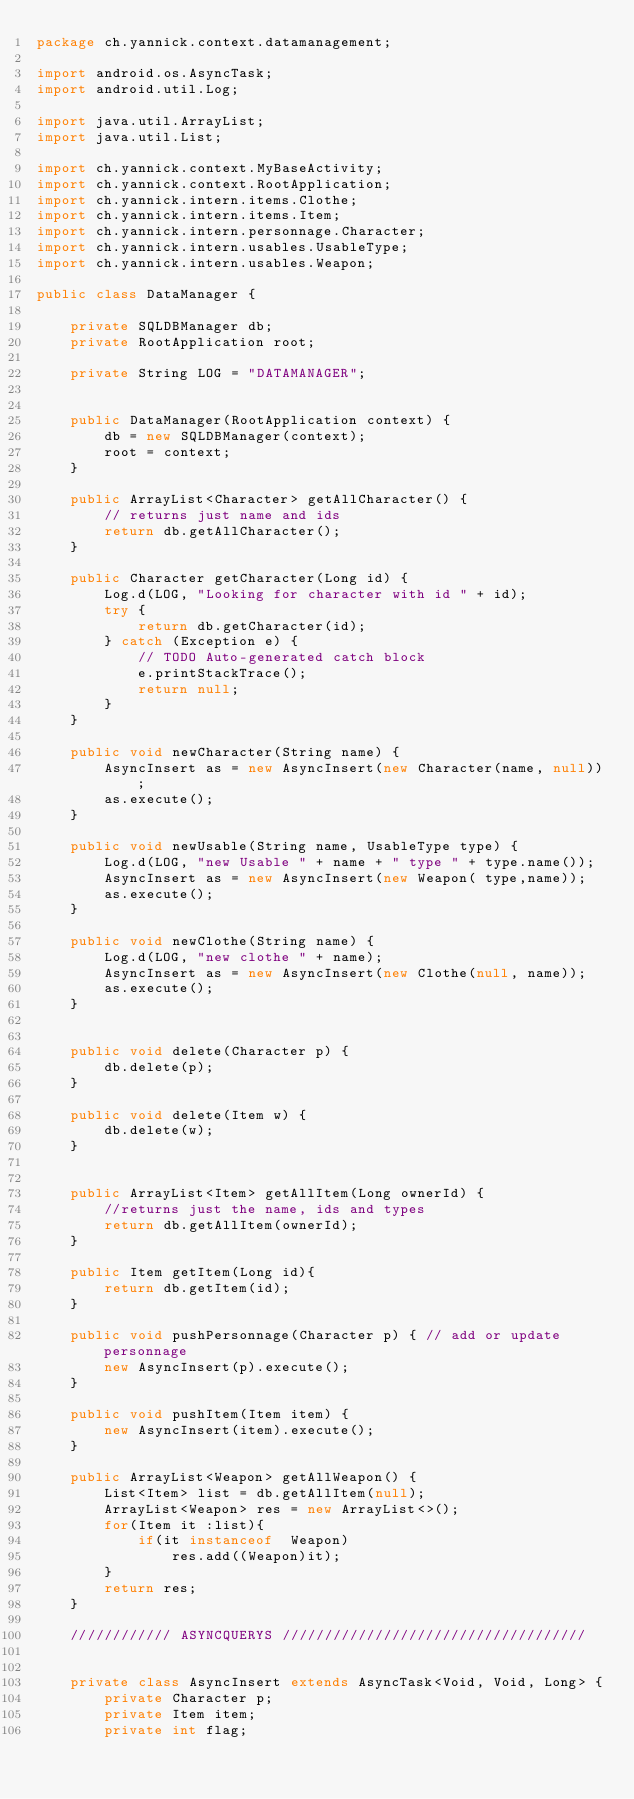Convert code to text. <code><loc_0><loc_0><loc_500><loc_500><_Java_>package ch.yannick.context.datamanagement;

import android.os.AsyncTask;
import android.util.Log;

import java.util.ArrayList;
import java.util.List;

import ch.yannick.context.MyBaseActivity;
import ch.yannick.context.RootApplication;
import ch.yannick.intern.items.Clothe;
import ch.yannick.intern.items.Item;
import ch.yannick.intern.personnage.Character;
import ch.yannick.intern.usables.UsableType;
import ch.yannick.intern.usables.Weapon;

public class DataManager {

    private SQLDBManager db;
    private RootApplication root;

    private String LOG = "DATAMANAGER";


    public DataManager(RootApplication context) {
        db = new SQLDBManager(context);
        root = context;
    }

    public ArrayList<Character> getAllCharacter() {
        // returns just name and ids
        return db.getAllCharacter();
    }

    public Character getCharacter(Long id) {
        Log.d(LOG, "Looking for character with id " + id);
        try {
            return db.getCharacter(id);
        } catch (Exception e) {
            // TODO Auto-generated catch block
            e.printStackTrace();
            return null;
        }
    }

    public void newCharacter(String name) {
        AsyncInsert as = new AsyncInsert(new Character(name, null));
        as.execute();
    }

    public void newUsable(String name, UsableType type) {
        Log.d(LOG, "new Usable " + name + " type " + type.name());
        AsyncInsert as = new AsyncInsert(new Weapon( type,name));
        as.execute();
    }

    public void newClothe(String name) {
        Log.d(LOG, "new clothe " + name);
        AsyncInsert as = new AsyncInsert(new Clothe(null, name));
        as.execute();
    }


    public void delete(Character p) {
        db.delete(p);
    }

    public void delete(Item w) {
        db.delete(w);
    }


    public ArrayList<Item> getAllItem(Long ownerId) {
        //returns just the name, ids and types
        return db.getAllItem(ownerId);
    }

    public Item getItem(Long id){
        return db.getItem(id);
    }

    public void pushPersonnage(Character p) { // add or update personnage
        new AsyncInsert(p).execute();
    }

    public void pushItem(Item item) {
        new AsyncInsert(item).execute();
    }

    public ArrayList<Weapon> getAllWeapon() {
        List<Item> list = db.getAllItem(null);
        ArrayList<Weapon> res = new ArrayList<>();
        for(Item it :list){
            if(it instanceof  Weapon)
                res.add((Weapon)it);
        }
        return res;
    }

    //////////// ASYNCQUERYS ////////////////////////////////////


    private class AsyncInsert extends AsyncTask<Void, Void, Long> {
        private Character p;
        private Item item;
        private int flag;
</code> 